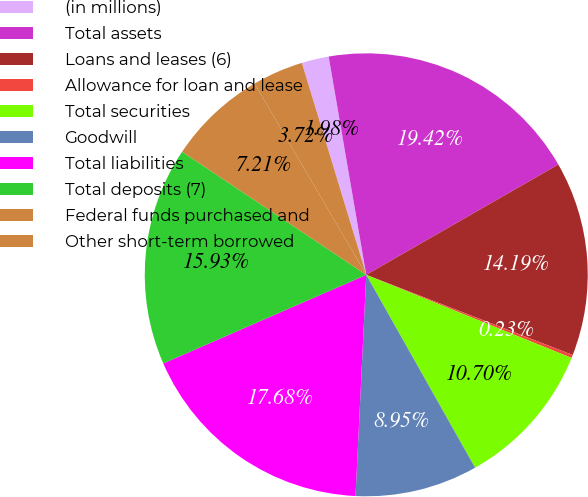Convert chart to OTSL. <chart><loc_0><loc_0><loc_500><loc_500><pie_chart><fcel>(in millions)<fcel>Total assets<fcel>Loans and leases (6)<fcel>Allowance for loan and lease<fcel>Total securities<fcel>Goodwill<fcel>Total liabilities<fcel>Total deposits (7)<fcel>Federal funds purchased and<fcel>Other short-term borrowed<nl><fcel>1.98%<fcel>19.42%<fcel>14.19%<fcel>0.23%<fcel>10.7%<fcel>8.95%<fcel>17.68%<fcel>15.93%<fcel>7.21%<fcel>3.72%<nl></chart> 